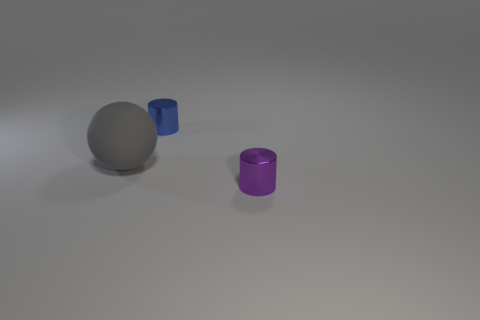Add 3 large gray matte cylinders. How many objects exist? 6 Subtract all balls. How many objects are left? 2 Add 2 tiny blue metallic cylinders. How many tiny blue metallic cylinders are left? 3 Add 1 rubber objects. How many rubber objects exist? 2 Subtract all purple cylinders. How many cylinders are left? 1 Subtract 1 purple cylinders. How many objects are left? 2 Subtract 1 balls. How many balls are left? 0 Subtract all gray cylinders. Subtract all red blocks. How many cylinders are left? 2 Subtract all blue cylinders. How many cyan balls are left? 0 Subtract all tiny blue metal objects. Subtract all cyan blocks. How many objects are left? 2 